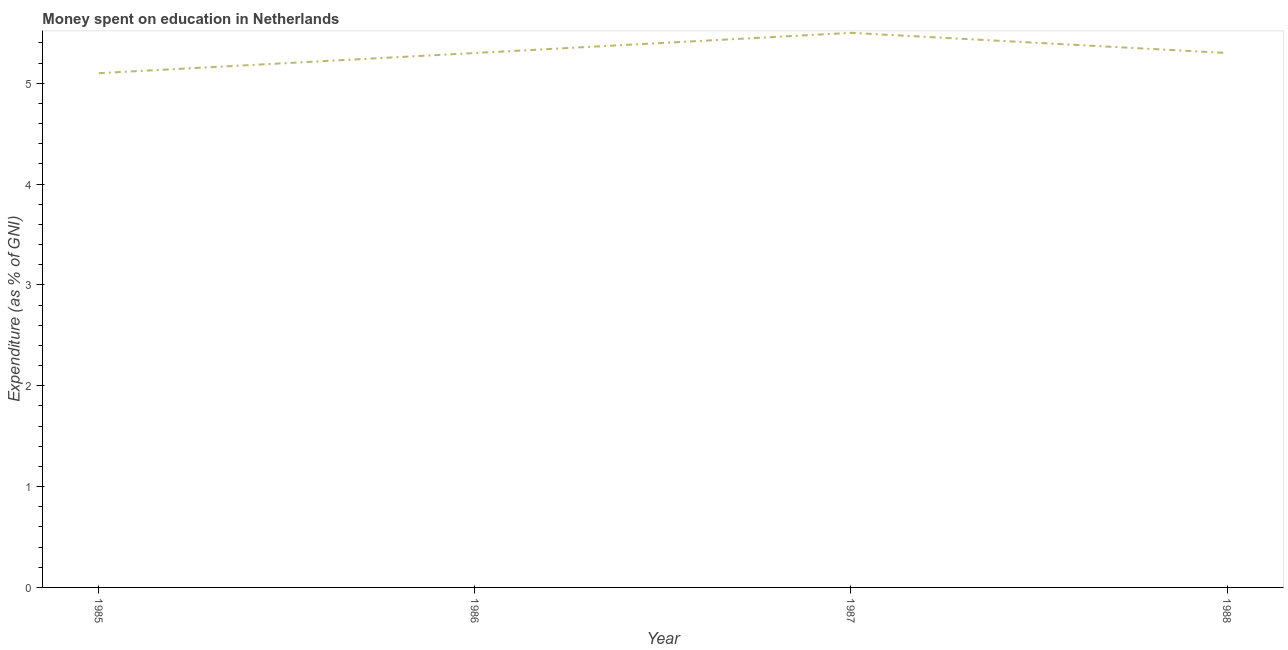Across all years, what is the maximum expenditure on education?
Ensure brevity in your answer.  5.5. In which year was the expenditure on education maximum?
Offer a terse response. 1987. In which year was the expenditure on education minimum?
Your answer should be very brief. 1985. What is the sum of the expenditure on education?
Make the answer very short. 21.2. What is the difference between the expenditure on education in 1986 and 1987?
Ensure brevity in your answer.  -0.2. What is the average expenditure on education per year?
Offer a terse response. 5.3. Do a majority of the years between 1985 and 1988 (inclusive) have expenditure on education greater than 0.8 %?
Provide a short and direct response. Yes. What is the difference between the highest and the second highest expenditure on education?
Offer a very short reply. 0.2. Is the sum of the expenditure on education in 1985 and 1987 greater than the maximum expenditure on education across all years?
Keep it short and to the point. Yes. What is the difference between the highest and the lowest expenditure on education?
Offer a terse response. 0.4. In how many years, is the expenditure on education greater than the average expenditure on education taken over all years?
Make the answer very short. 1. How many lines are there?
Make the answer very short. 1. How many years are there in the graph?
Offer a very short reply. 4. Are the values on the major ticks of Y-axis written in scientific E-notation?
Keep it short and to the point. No. Does the graph contain grids?
Provide a short and direct response. No. What is the title of the graph?
Provide a succinct answer. Money spent on education in Netherlands. What is the label or title of the Y-axis?
Give a very brief answer. Expenditure (as % of GNI). What is the Expenditure (as % of GNI) of 1986?
Make the answer very short. 5.3. What is the difference between the Expenditure (as % of GNI) in 1985 and 1988?
Ensure brevity in your answer.  -0.2. What is the difference between the Expenditure (as % of GNI) in 1986 and 1987?
Keep it short and to the point. -0.2. What is the difference between the Expenditure (as % of GNI) in 1986 and 1988?
Make the answer very short. 0. What is the difference between the Expenditure (as % of GNI) in 1987 and 1988?
Provide a succinct answer. 0.2. What is the ratio of the Expenditure (as % of GNI) in 1985 to that in 1986?
Your answer should be very brief. 0.96. What is the ratio of the Expenditure (as % of GNI) in 1985 to that in 1987?
Ensure brevity in your answer.  0.93. What is the ratio of the Expenditure (as % of GNI) in 1987 to that in 1988?
Provide a short and direct response. 1.04. 